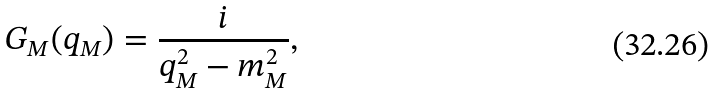<formula> <loc_0><loc_0><loc_500><loc_500>G _ { M } ( q _ { M } ) = \frac { i } { q _ { M } ^ { 2 } - m _ { M } ^ { 2 } } ,</formula> 